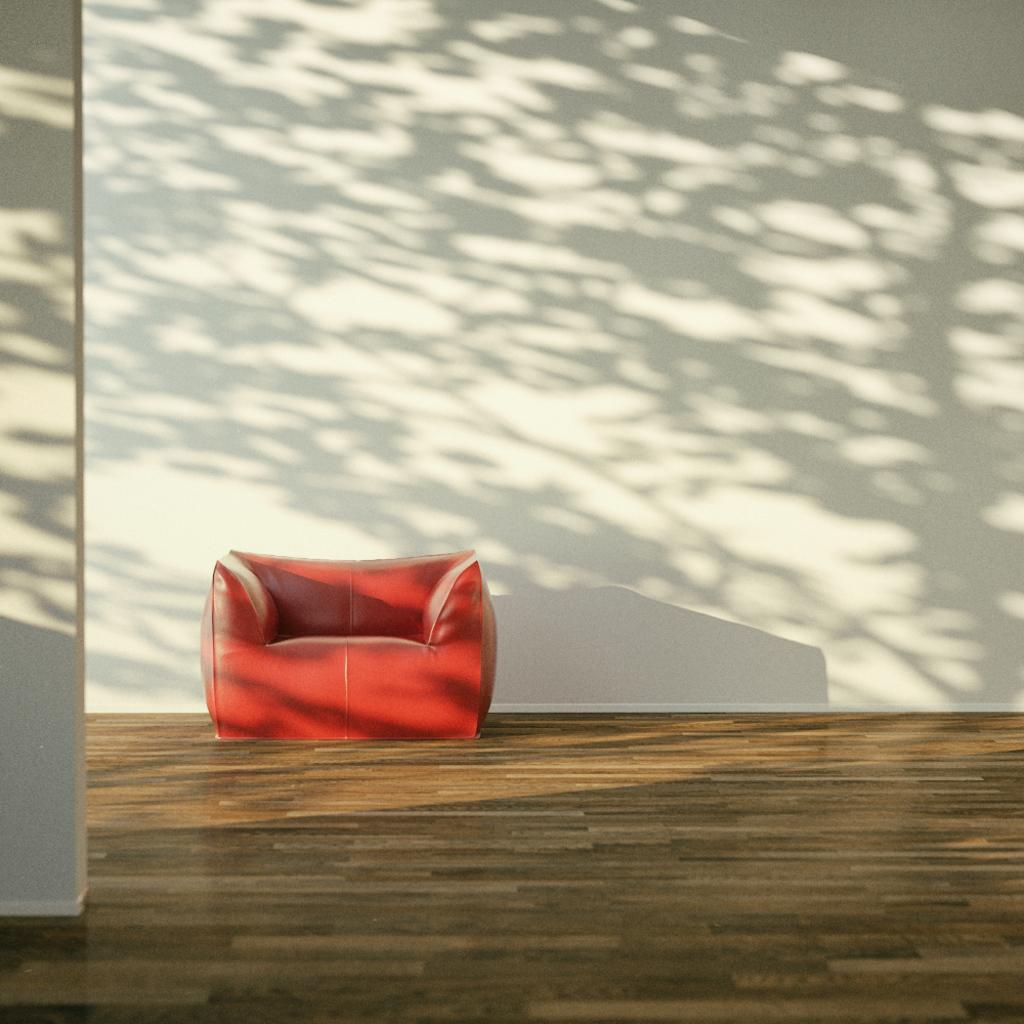What type of furniture is in the image? There is a sofa in the image. What part of the room is visible in the image? The floor is visible in the image. What architectural feature can be seen in the image? There is a wall in the image. What type of error can be seen on the wall in the image? There is no error visible on the wall in the image. What type of pet is sitting on the sofa in the image? There is no pet present in the image. 